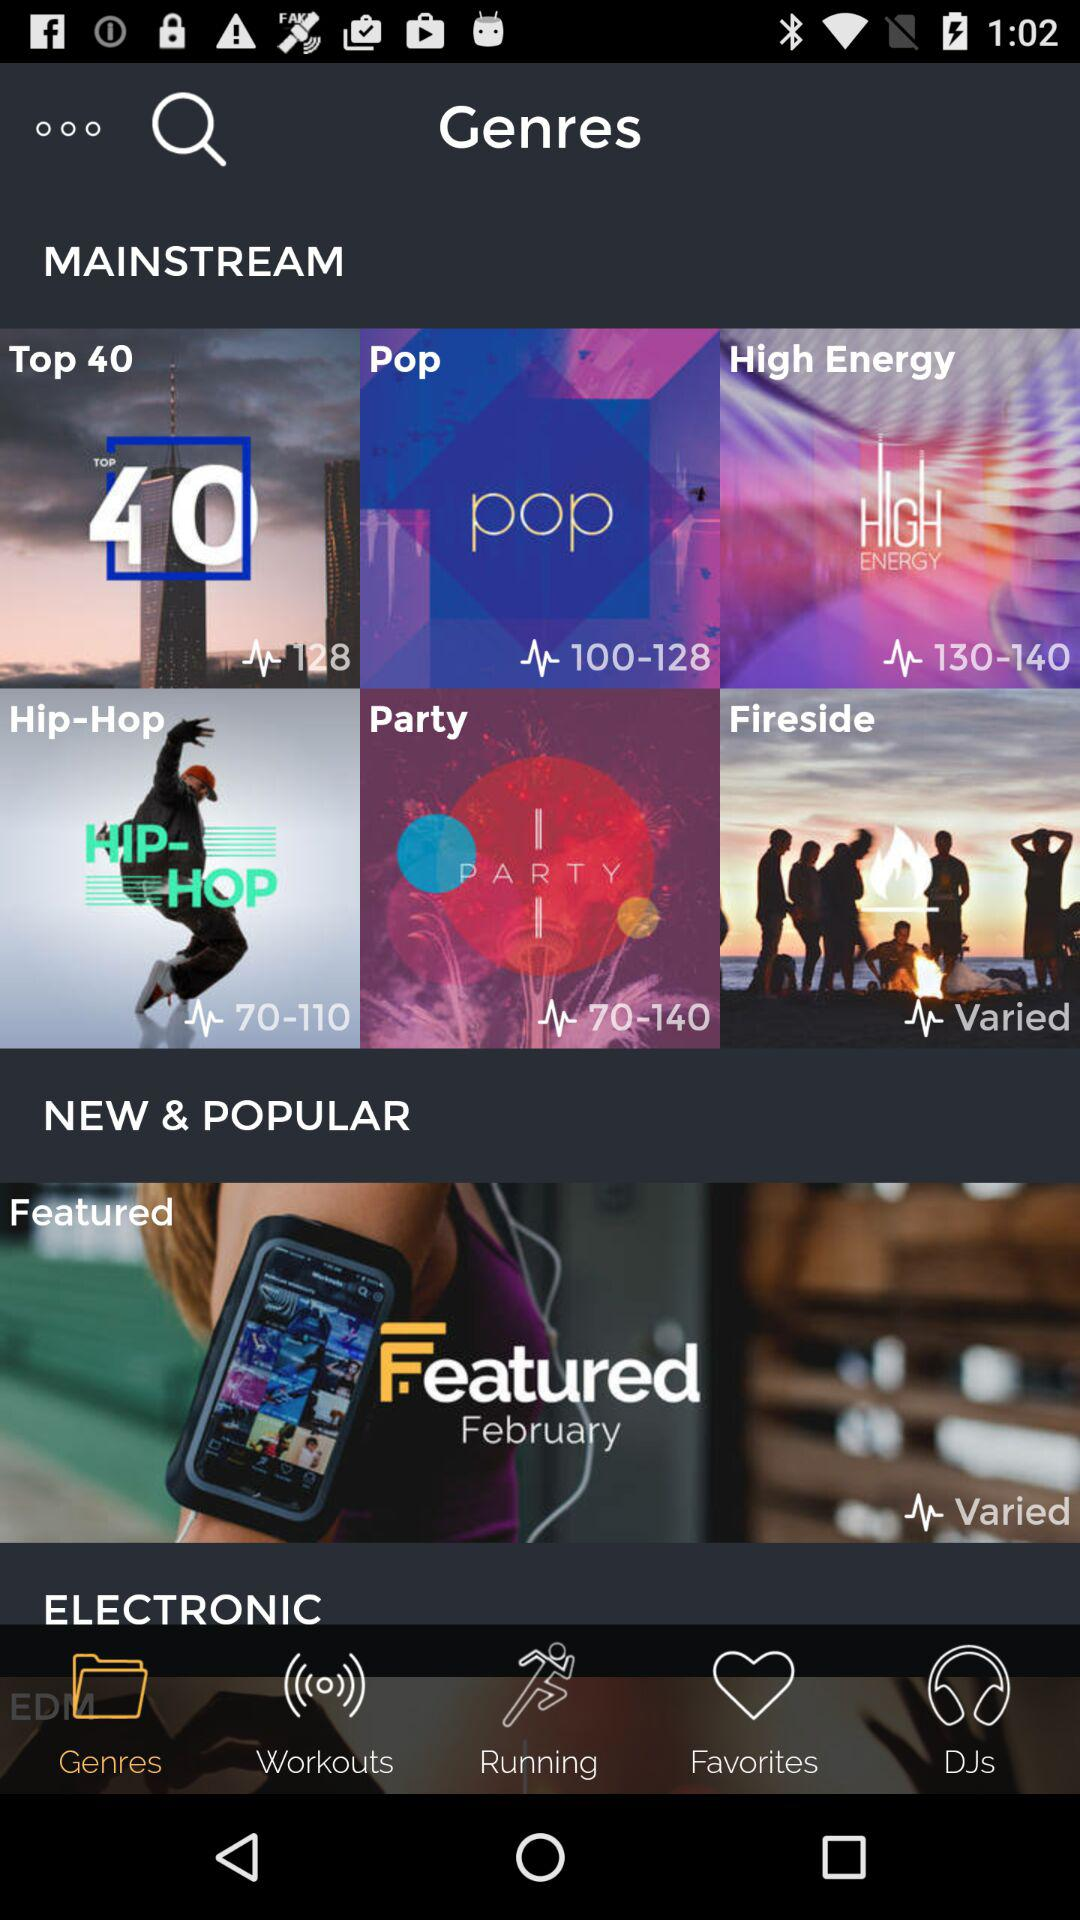What kind of workouts are available?
When the provided information is insufficient, respond with <no answer>. <no answer> 